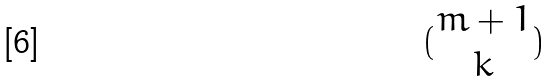Convert formula to latex. <formula><loc_0><loc_0><loc_500><loc_500>( \begin{matrix} m + 1 \\ k \end{matrix} )</formula> 